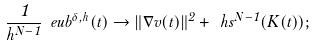<formula> <loc_0><loc_0><loc_500><loc_500>\frac { 1 } { h ^ { N - 1 } } \ e u b ^ { \delta , h } ( t ) \to \| \nabla v ( t ) \| ^ { 2 } + \ h s ^ { N - 1 } ( K ( t ) ) ;</formula> 